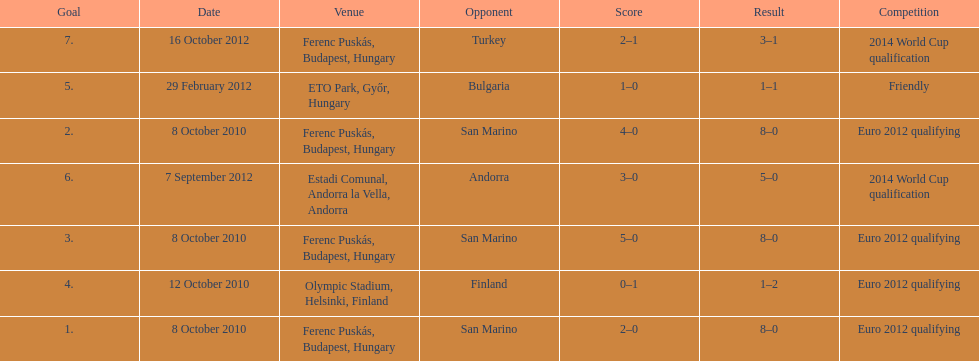How many non-qualifying games did he score in? 1. 